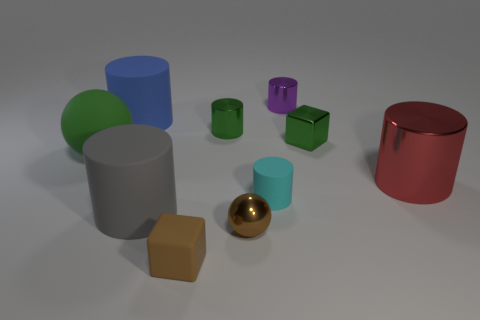Subtract all gray cylinders. How many cylinders are left? 5 Subtract all small green cylinders. How many cylinders are left? 5 Subtract all gray cylinders. Subtract all red spheres. How many cylinders are left? 5 Subtract all cylinders. How many objects are left? 4 Subtract 0 red spheres. How many objects are left? 10 Subtract all tiny matte things. Subtract all matte blocks. How many objects are left? 7 Add 5 big metal cylinders. How many big metal cylinders are left? 6 Add 6 big gray shiny blocks. How many big gray shiny blocks exist? 6 